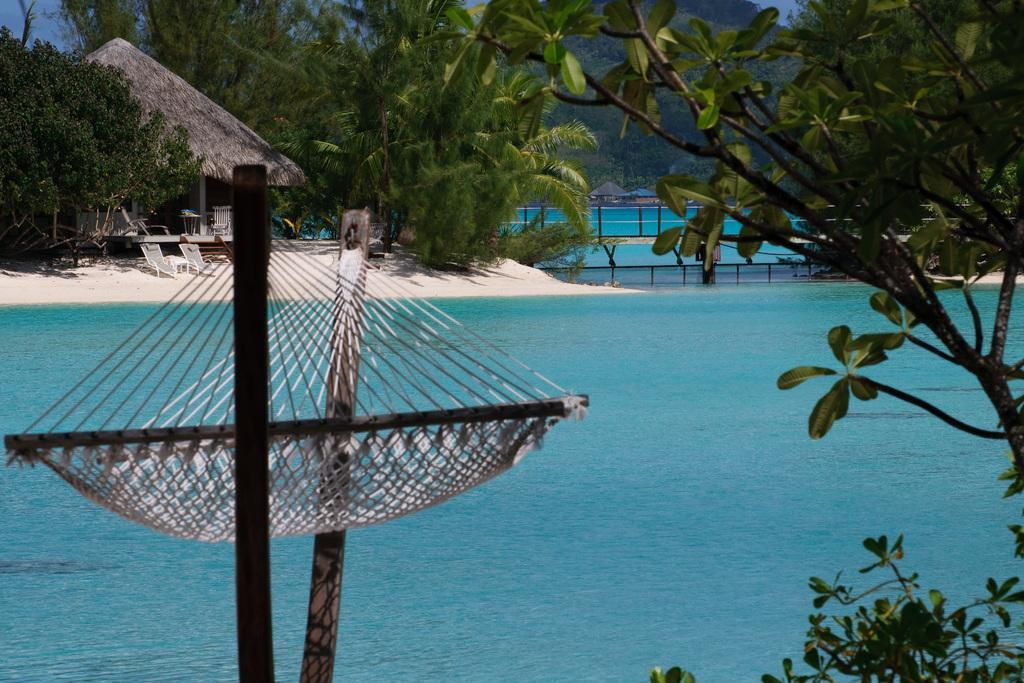What is the primary element visible in the image? There is water in the image. What type of furniture can be seen in the image? There are chairs in the image. What type of structure is present in the image? There is a beach hut in the image. What type of vegetation is visible in the image? There are trees in the image. Can you describe any other objects present in the image? There are other unspecified objects in the image. How does the ladybug contribute to the decision-making process in the image? There is no ladybug present in the image, so it cannot contribute to any decision-making process. 